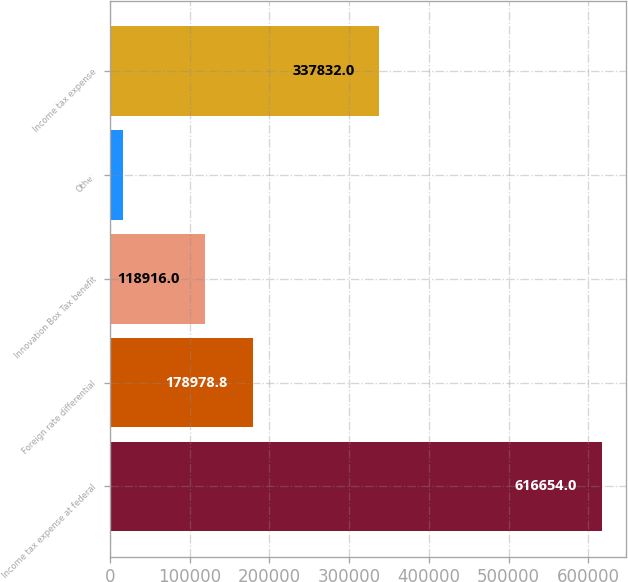Convert chart to OTSL. <chart><loc_0><loc_0><loc_500><loc_500><bar_chart><fcel>Income tax expense at federal<fcel>Foreign rate differential<fcel>Innovation Box Tax benefit<fcel>Other<fcel>Income tax expense<nl><fcel>616654<fcel>178979<fcel>118916<fcel>16026<fcel>337832<nl></chart> 